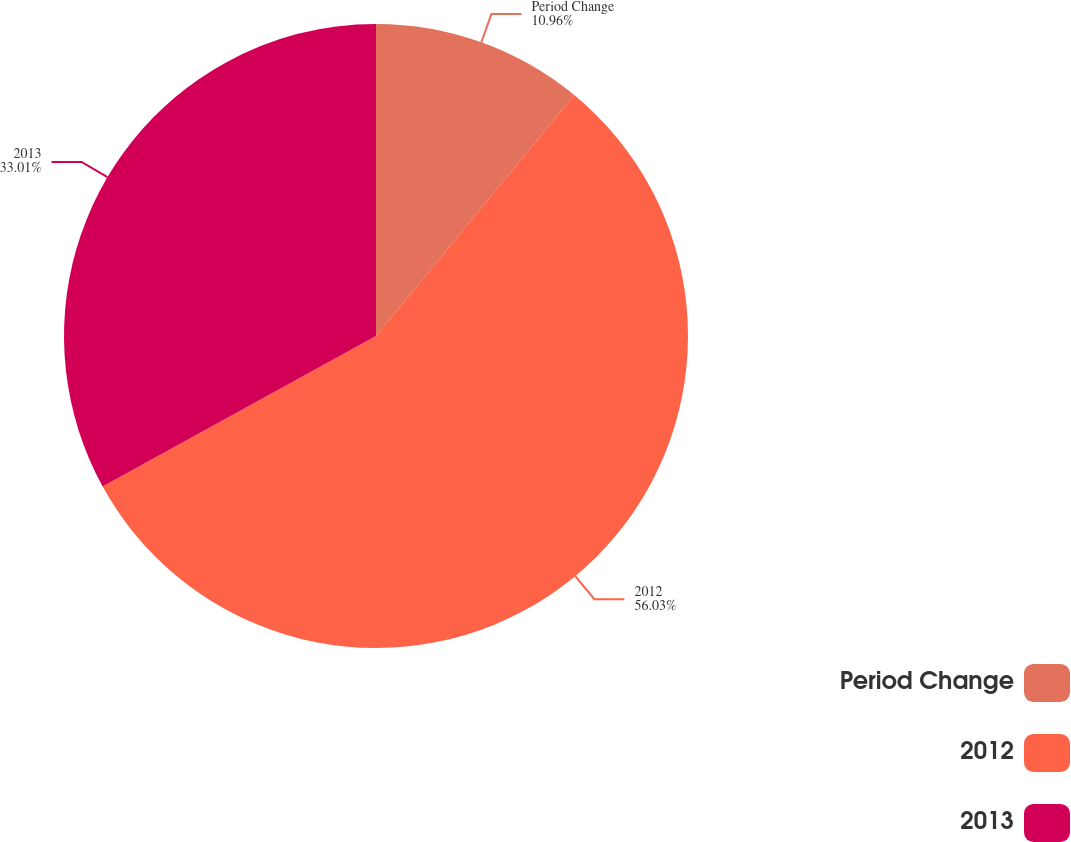Convert chart. <chart><loc_0><loc_0><loc_500><loc_500><pie_chart><fcel>Period Change<fcel>2012<fcel>2013<nl><fcel>10.96%<fcel>56.04%<fcel>33.01%<nl></chart> 